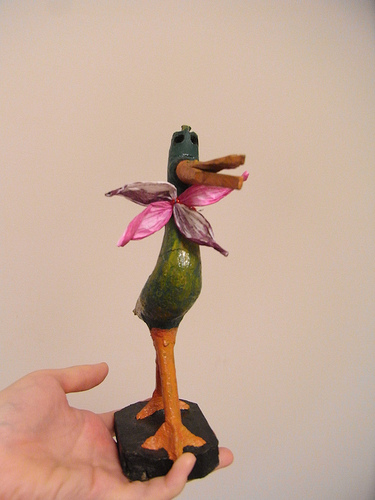<image>
Is there a pedestal behind the flower? No. The pedestal is not behind the flower. From this viewpoint, the pedestal appears to be positioned elsewhere in the scene. 